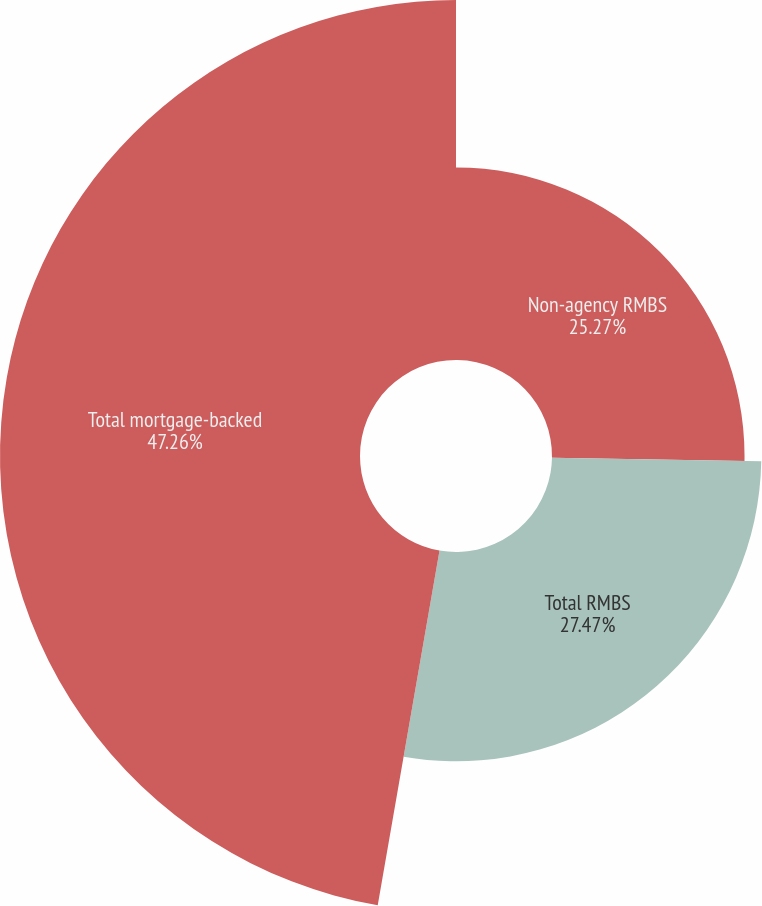Convert chart. <chart><loc_0><loc_0><loc_500><loc_500><pie_chart><fcel>Non-agency RMBS<fcel>Total RMBS<fcel>Total mortgage-backed<nl><fcel>25.27%<fcel>27.47%<fcel>47.25%<nl></chart> 